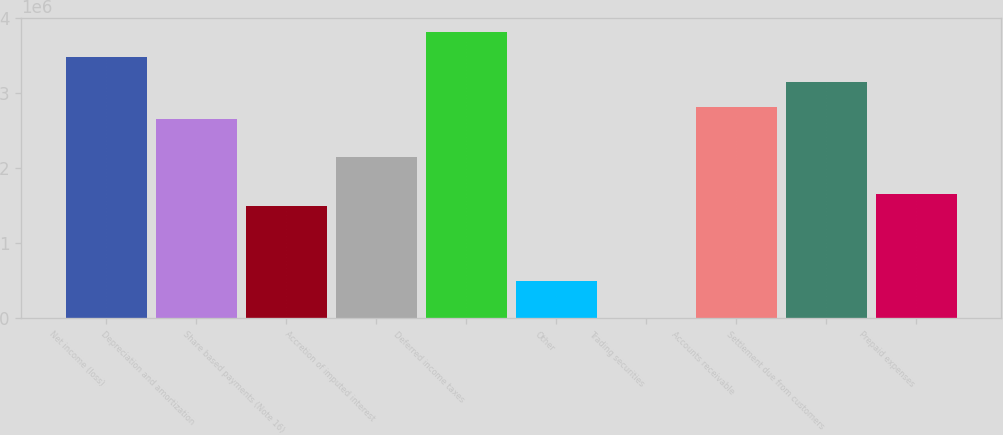Convert chart to OTSL. <chart><loc_0><loc_0><loc_500><loc_500><bar_chart><fcel>Net income (loss)<fcel>Depreciation and amortization<fcel>Share based payments (Note 16)<fcel>Accretion of imputed interest<fcel>Deferred income taxes<fcel>Other<fcel>Trading securities<fcel>Accounts receivable<fcel>Settlement due from customers<fcel>Prepaid expenses<nl><fcel>3.4817e+06<fcel>2.65334e+06<fcel>1.49362e+06<fcel>2.15632e+06<fcel>3.81305e+06<fcel>499581<fcel>2561<fcel>2.81901e+06<fcel>3.15036e+06<fcel>1.6593e+06<nl></chart> 